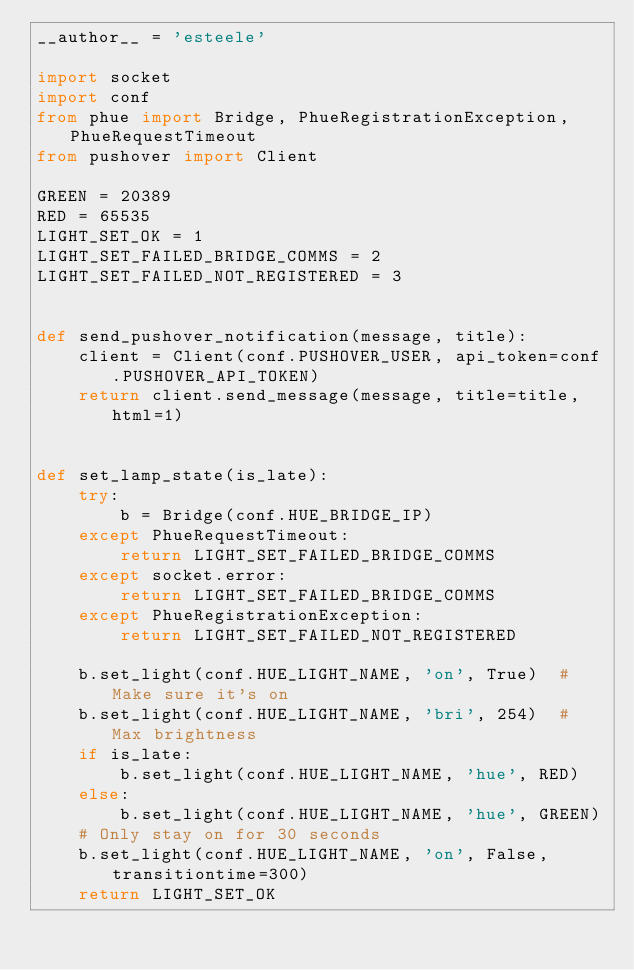Convert code to text. <code><loc_0><loc_0><loc_500><loc_500><_Python_>__author__ = 'esteele'

import socket
import conf
from phue import Bridge, PhueRegistrationException, PhueRequestTimeout
from pushover import Client

GREEN = 20389
RED = 65535
LIGHT_SET_OK = 1
LIGHT_SET_FAILED_BRIDGE_COMMS = 2
LIGHT_SET_FAILED_NOT_REGISTERED = 3


def send_pushover_notification(message, title):
    client = Client(conf.PUSHOVER_USER, api_token=conf.PUSHOVER_API_TOKEN)
    return client.send_message(message, title=title, html=1)


def set_lamp_state(is_late):
    try:
        b = Bridge(conf.HUE_BRIDGE_IP)
    except PhueRequestTimeout:
        return LIGHT_SET_FAILED_BRIDGE_COMMS
    except socket.error:
        return LIGHT_SET_FAILED_BRIDGE_COMMS
    except PhueRegistrationException:
        return LIGHT_SET_FAILED_NOT_REGISTERED

    b.set_light(conf.HUE_LIGHT_NAME, 'on', True)  # Make sure it's on
    b.set_light(conf.HUE_LIGHT_NAME, 'bri', 254)  # Max brightness
    if is_late:
        b.set_light(conf.HUE_LIGHT_NAME, 'hue', RED)
    else:
        b.set_light(conf.HUE_LIGHT_NAME, 'hue', GREEN)
    # Only stay on for 30 seconds
    b.set_light(conf.HUE_LIGHT_NAME, 'on', False, transitiontime=300)
    return LIGHT_SET_OK</code> 